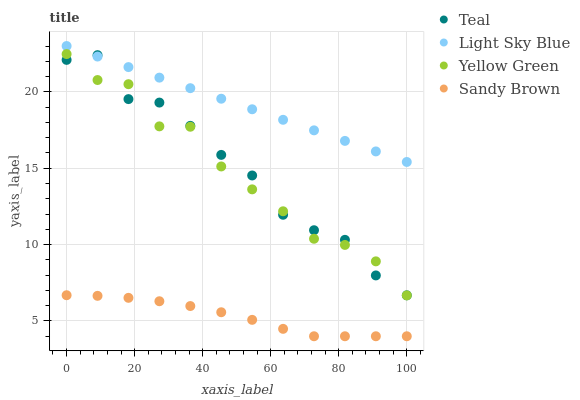Does Sandy Brown have the minimum area under the curve?
Answer yes or no. Yes. Does Light Sky Blue have the maximum area under the curve?
Answer yes or no. Yes. Does Yellow Green have the minimum area under the curve?
Answer yes or no. No. Does Yellow Green have the maximum area under the curve?
Answer yes or no. No. Is Light Sky Blue the smoothest?
Answer yes or no. Yes. Is Yellow Green the roughest?
Answer yes or no. Yes. Is Sandy Brown the smoothest?
Answer yes or no. No. Is Sandy Brown the roughest?
Answer yes or no. No. Does Sandy Brown have the lowest value?
Answer yes or no. Yes. Does Yellow Green have the lowest value?
Answer yes or no. No. Does Light Sky Blue have the highest value?
Answer yes or no. Yes. Does Yellow Green have the highest value?
Answer yes or no. No. Is Yellow Green less than Light Sky Blue?
Answer yes or no. Yes. Is Light Sky Blue greater than Sandy Brown?
Answer yes or no. Yes. Does Light Sky Blue intersect Teal?
Answer yes or no. Yes. Is Light Sky Blue less than Teal?
Answer yes or no. No. Is Light Sky Blue greater than Teal?
Answer yes or no. No. Does Yellow Green intersect Light Sky Blue?
Answer yes or no. No. 